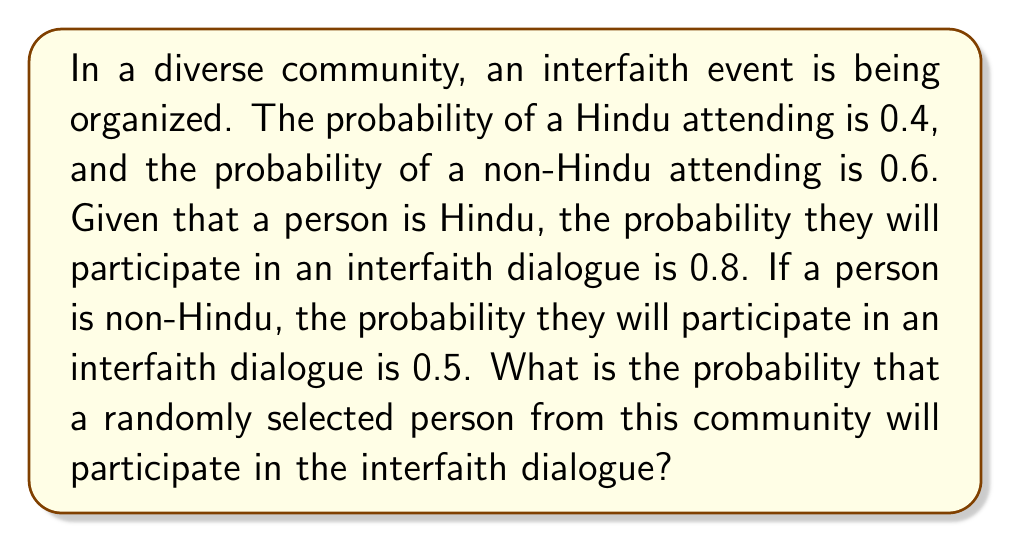Provide a solution to this math problem. Let's approach this step-by-step using the law of total probability:

1) Define events:
   H: Person is Hindu
   D: Person participates in interfaith dialogue

2) Given probabilities:
   $P(H) = 0.4$
   $P(H') = 1 - P(H) = 0.6$ (non-Hindu)
   $P(D|H) = 0.8$
   $P(D|H') = 0.5$

3) Law of Total Probability:
   $P(D) = P(D|H) \cdot P(H) + P(D|H') \cdot P(H')$

4) Substitute the values:
   $P(D) = 0.8 \cdot 0.4 + 0.5 \cdot 0.6$

5) Calculate:
   $P(D) = 0.32 + 0.30 = 0.62$

Therefore, the probability that a randomly selected person will participate in the interfaith dialogue is 0.62 or 62%.
Answer: $0.62$ 